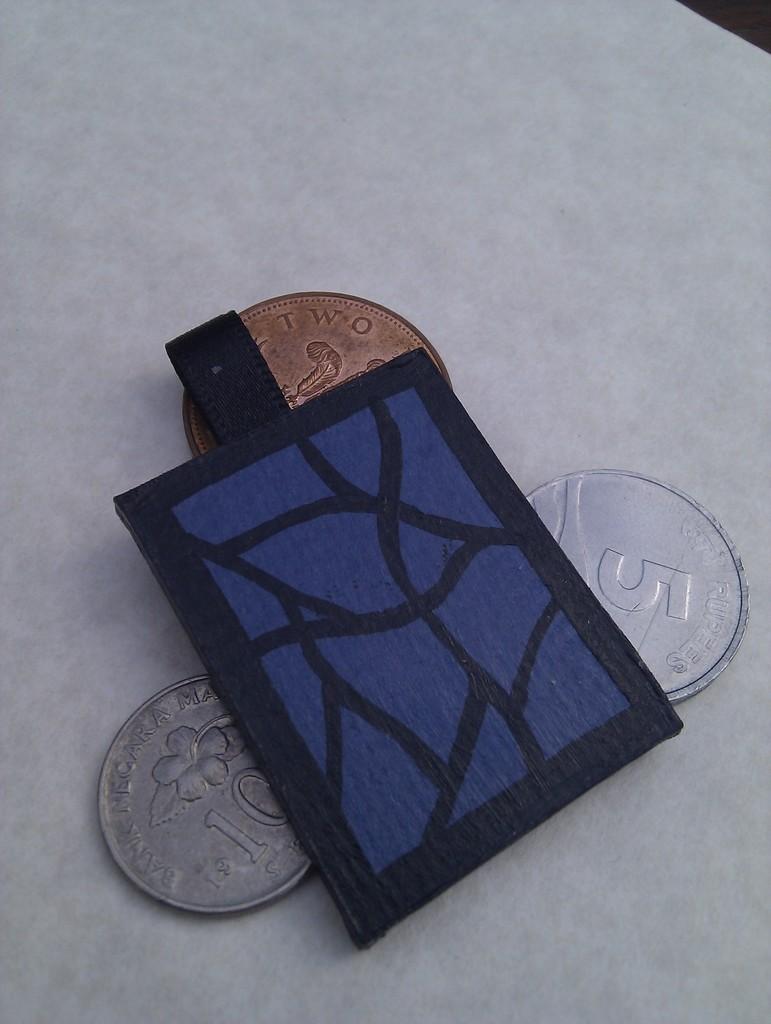Can you describe this image briefly? In this image we can see coins and small bag placed on the table. 